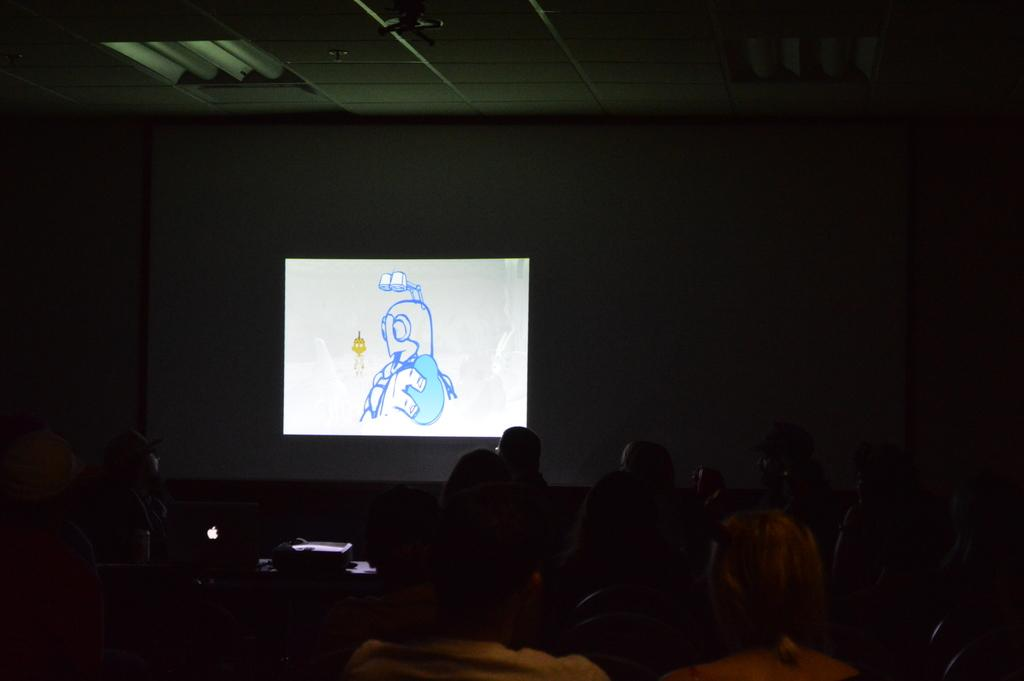How many people are in the image? There is a group of people in the image, but the exact number cannot be determined from the provided facts. What is in front of the people in the image? There is a screen in front of the people in the image. What part of the room can be seen in the image? The ceiling is visible in the image. What type of house is visible in the background of the image? There is no house visible in the image; it only shows a group of people, a screen, and a ceiling. What amusement park ride is the group of people riding in the image? There is no amusement park ride present in the image; it only shows a group of people, a screen, and a ceiling. 